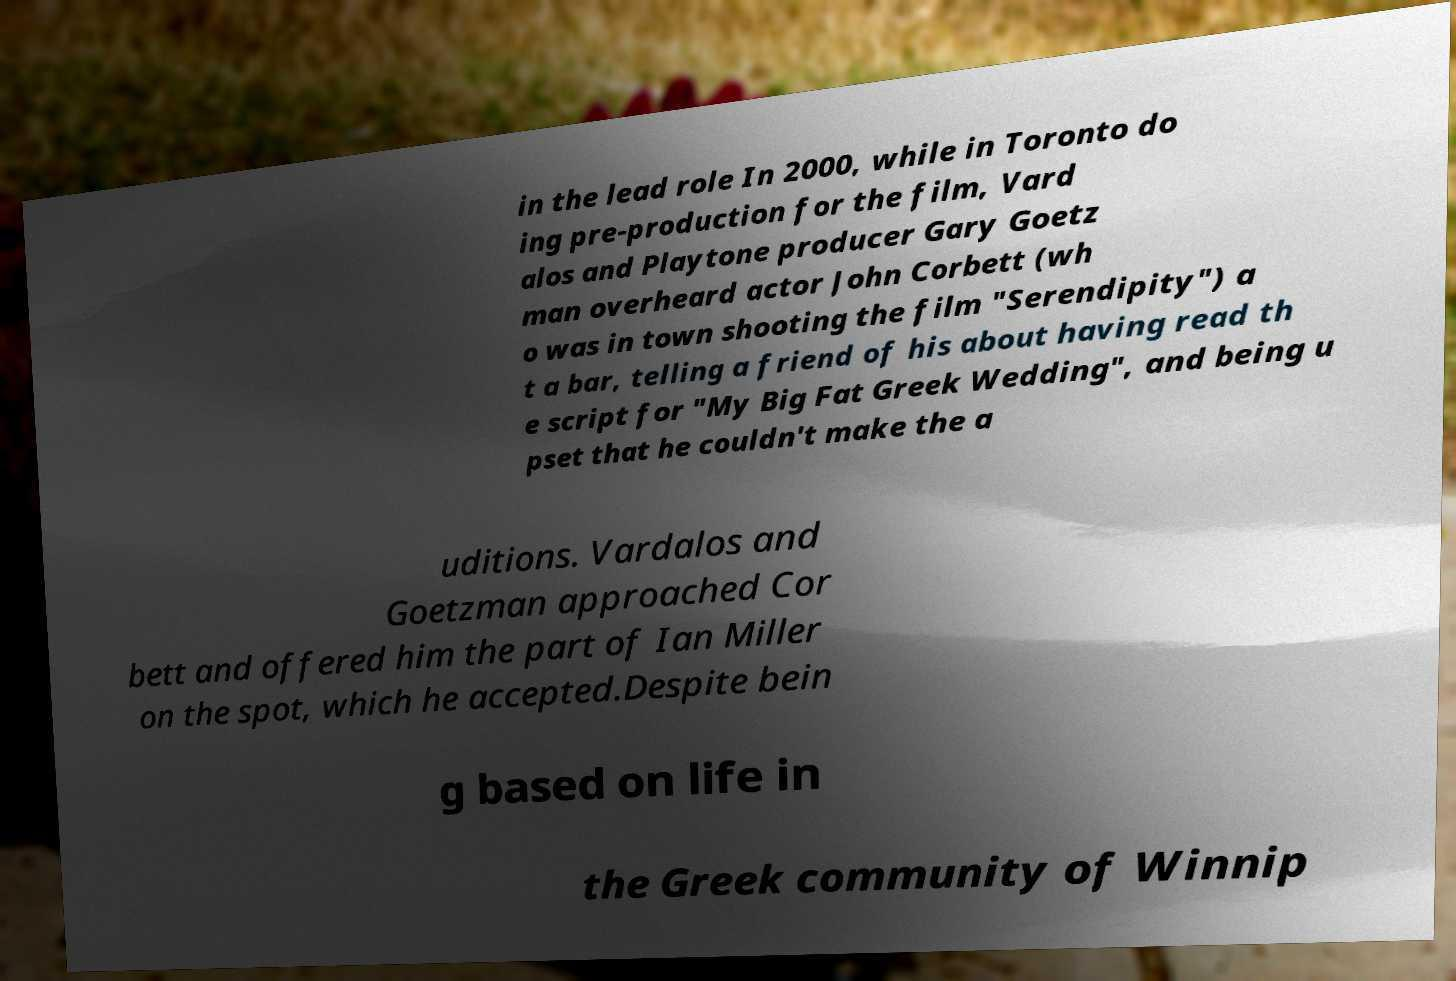For documentation purposes, I need the text within this image transcribed. Could you provide that? in the lead role In 2000, while in Toronto do ing pre-production for the film, Vard alos and Playtone producer Gary Goetz man overheard actor John Corbett (wh o was in town shooting the film "Serendipity") a t a bar, telling a friend of his about having read th e script for "My Big Fat Greek Wedding", and being u pset that he couldn't make the a uditions. Vardalos and Goetzman approached Cor bett and offered him the part of Ian Miller on the spot, which he accepted.Despite bein g based on life in the Greek community of Winnip 